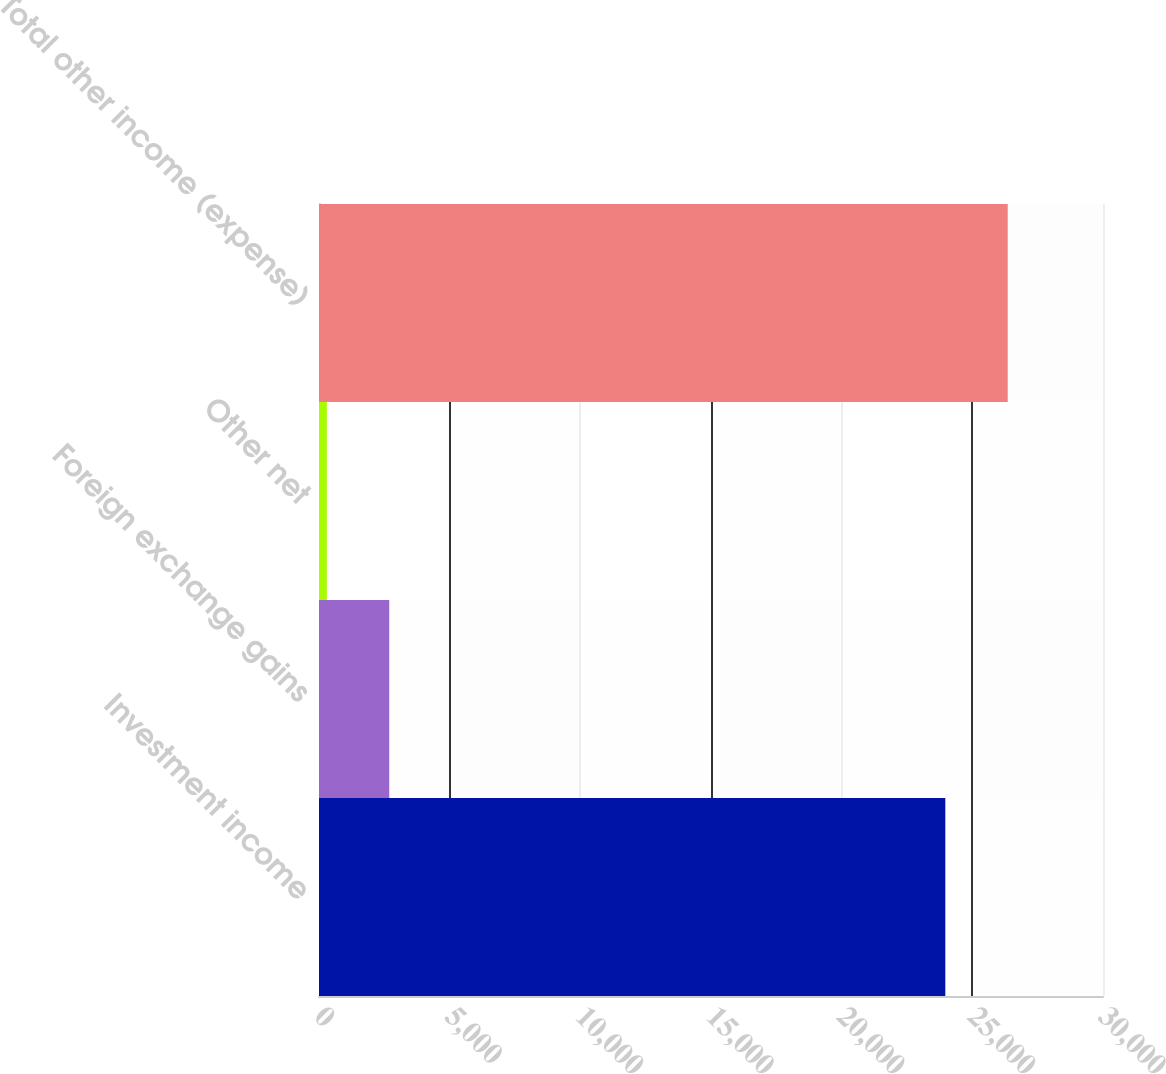<chart> <loc_0><loc_0><loc_500><loc_500><bar_chart><fcel>Investment income<fcel>Foreign exchange gains<fcel>Other net<fcel>Total other income (expense)<nl><fcel>23966<fcel>2688.1<fcel>299<fcel>26355.1<nl></chart> 